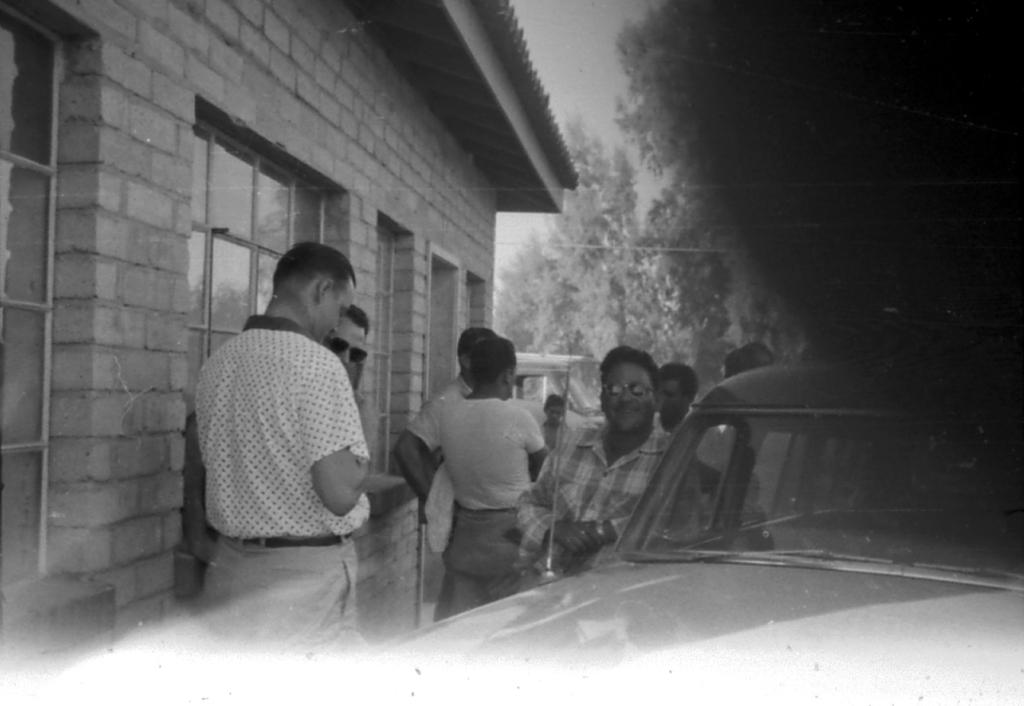What is happening in the image? There is a group of people standing in the image. What is in front of the group of people? There is a vehicle in front of the group of people. What can be seen in the background of the image? There is a building, trees, and the sky visible in the background of the image. What is the color scheme of the image? The image is in black and white. What degree of temperature is being experienced by the people in the image? The image is in black and white, so it is not possible to determine the temperature or any degrees related to it. Is there a crook present in the image? There is no mention of a crook or any person associated with criminal activity in the image. 